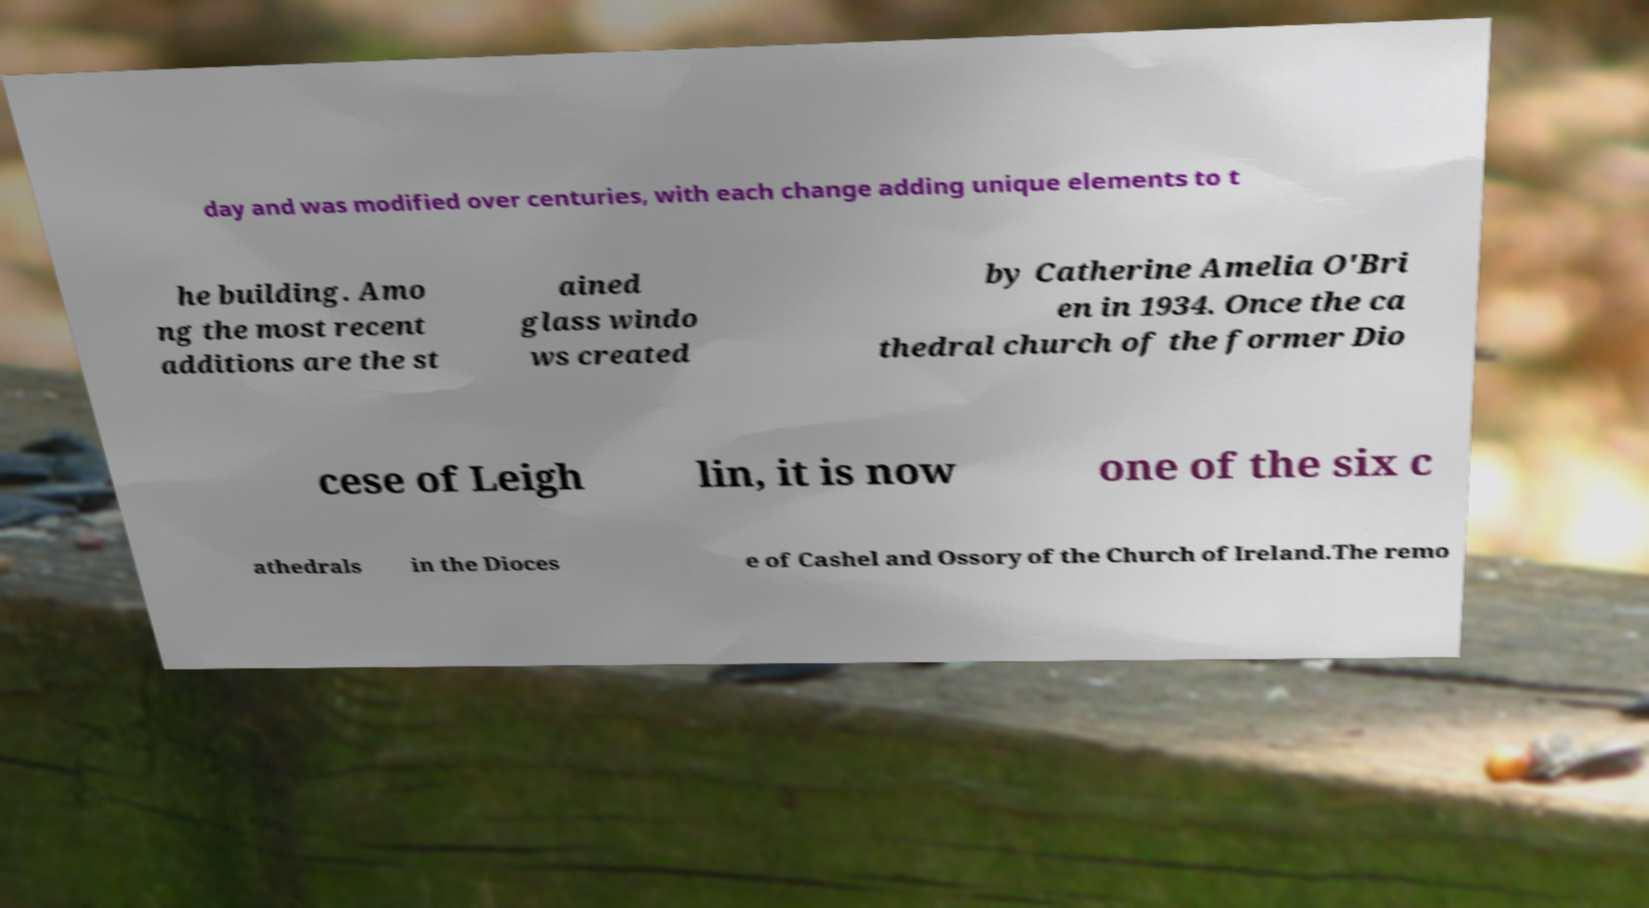Can you read and provide the text displayed in the image?This photo seems to have some interesting text. Can you extract and type it out for me? day and was modified over centuries, with each change adding unique elements to t he building. Amo ng the most recent additions are the st ained glass windo ws created by Catherine Amelia O'Bri en in 1934. Once the ca thedral church of the former Dio cese of Leigh lin, it is now one of the six c athedrals in the Dioces e of Cashel and Ossory of the Church of Ireland.The remo 